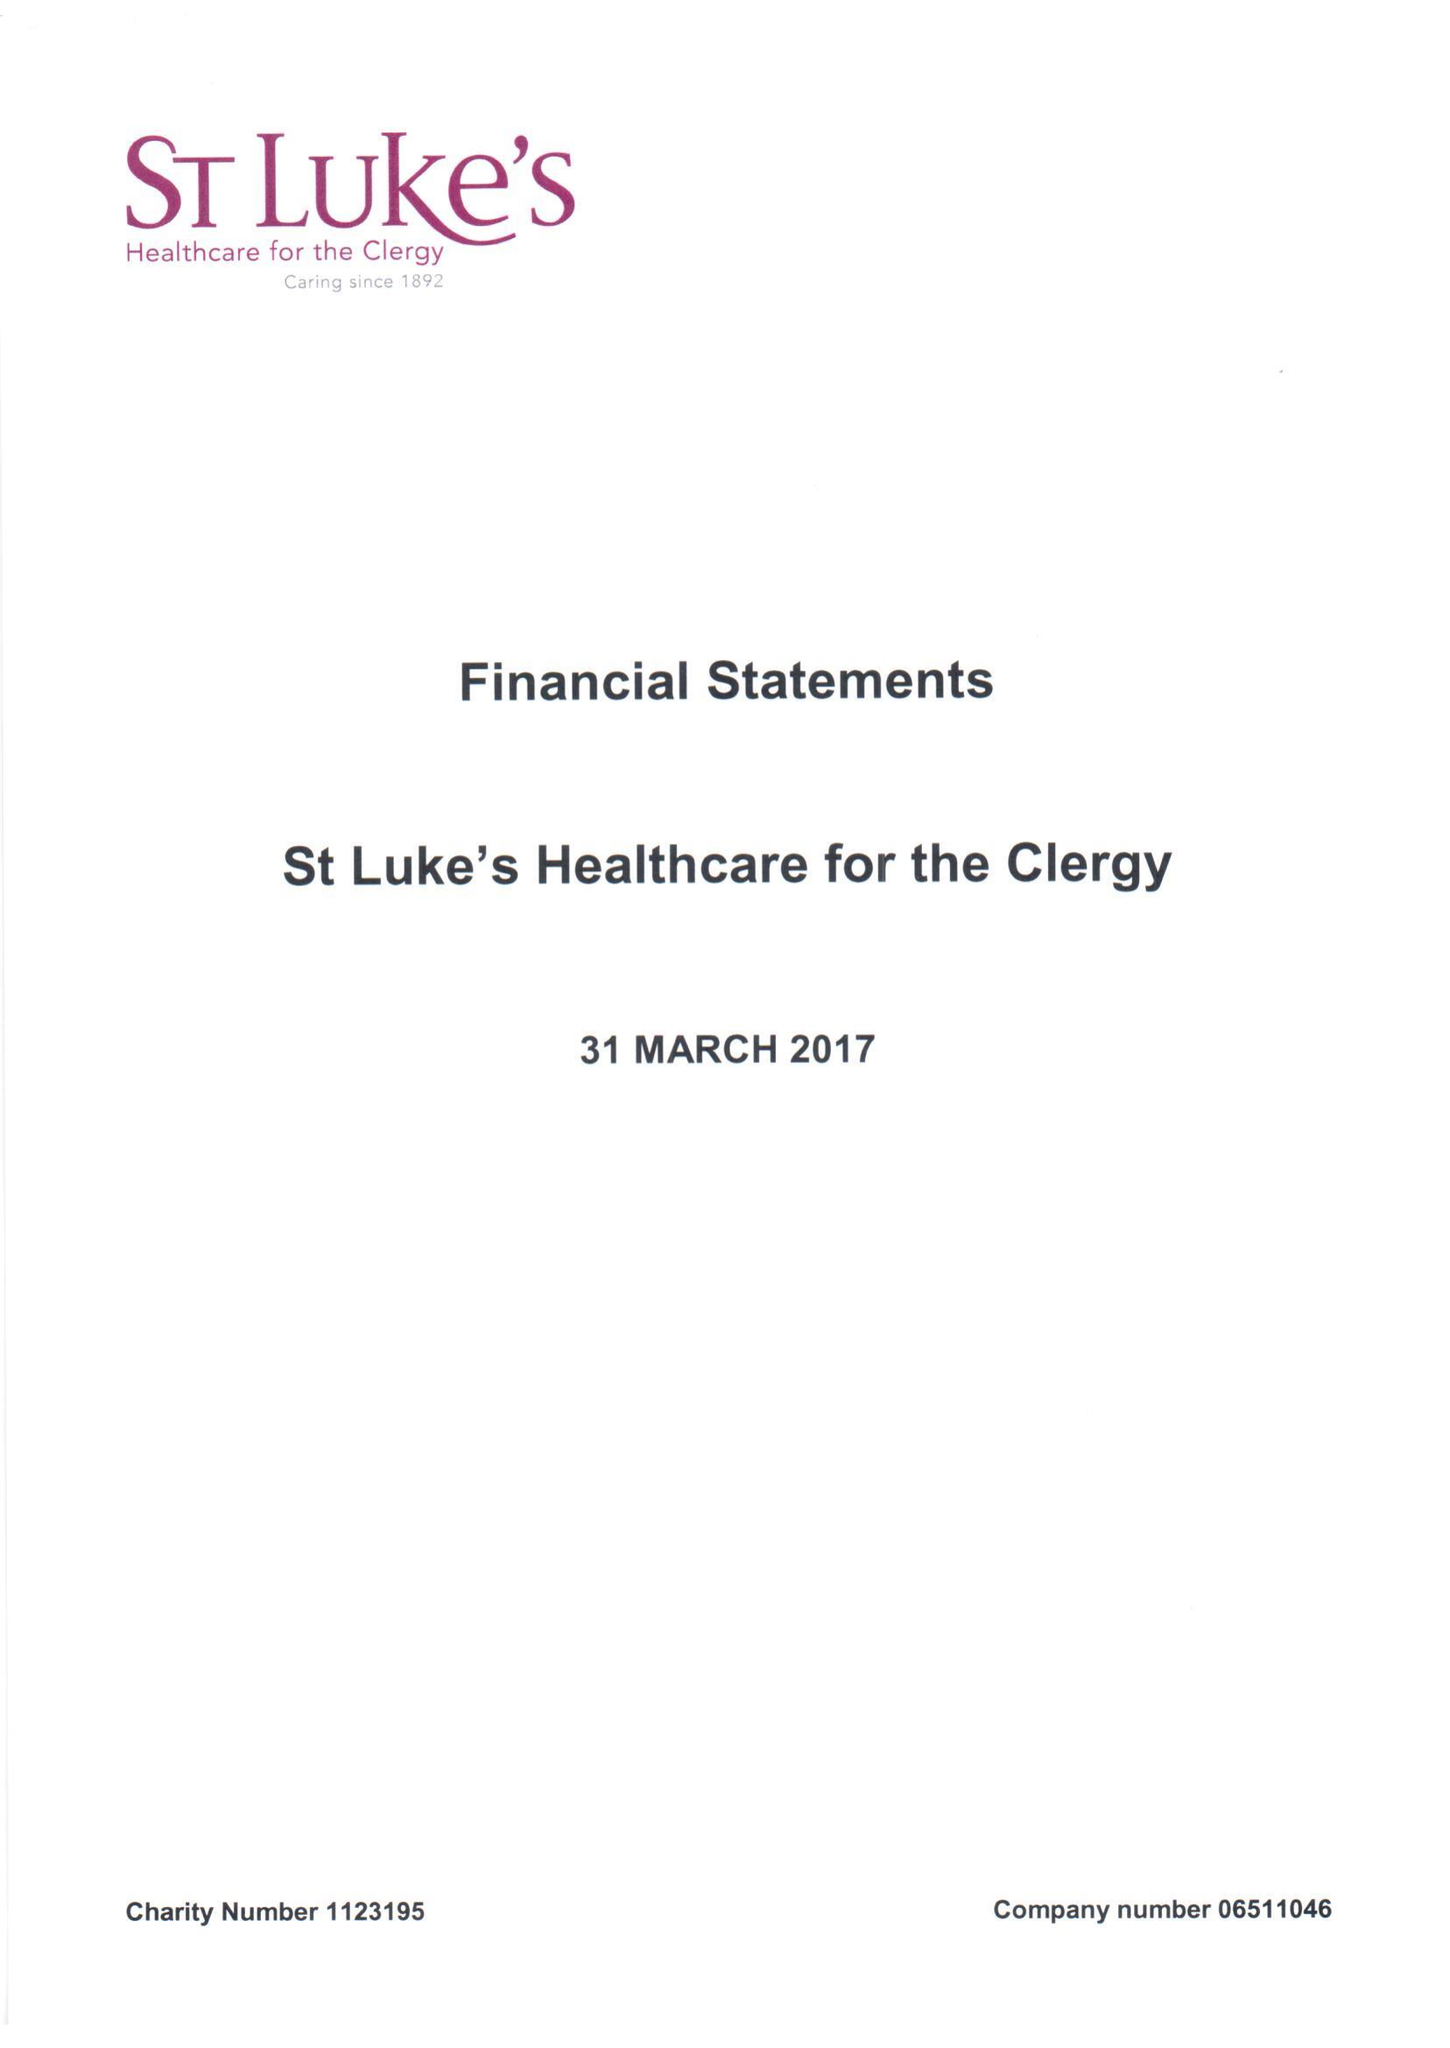What is the value for the report_date?
Answer the question using a single word or phrase. 2017-03-31 